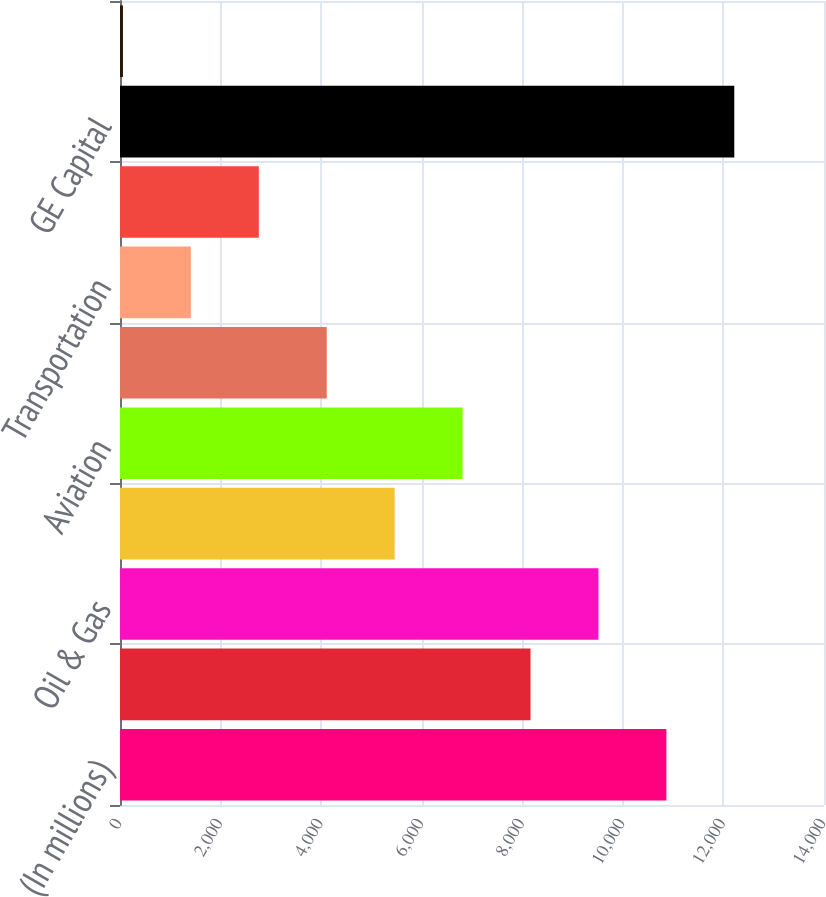Convert chart. <chart><loc_0><loc_0><loc_500><loc_500><bar_chart><fcel>(In millions)<fcel>Power & Water<fcel>Oil & Gas<fcel>Energy Management<fcel>Aviation<fcel>Healthcare<fcel>Transportation<fcel>Home & Business Solutions<fcel>GE Capital<fcel>Corporate items and<nl><fcel>10865.4<fcel>8163.8<fcel>9514.6<fcel>5462.2<fcel>6813<fcel>4111.4<fcel>1409.8<fcel>2760.6<fcel>12216.2<fcel>59<nl></chart> 